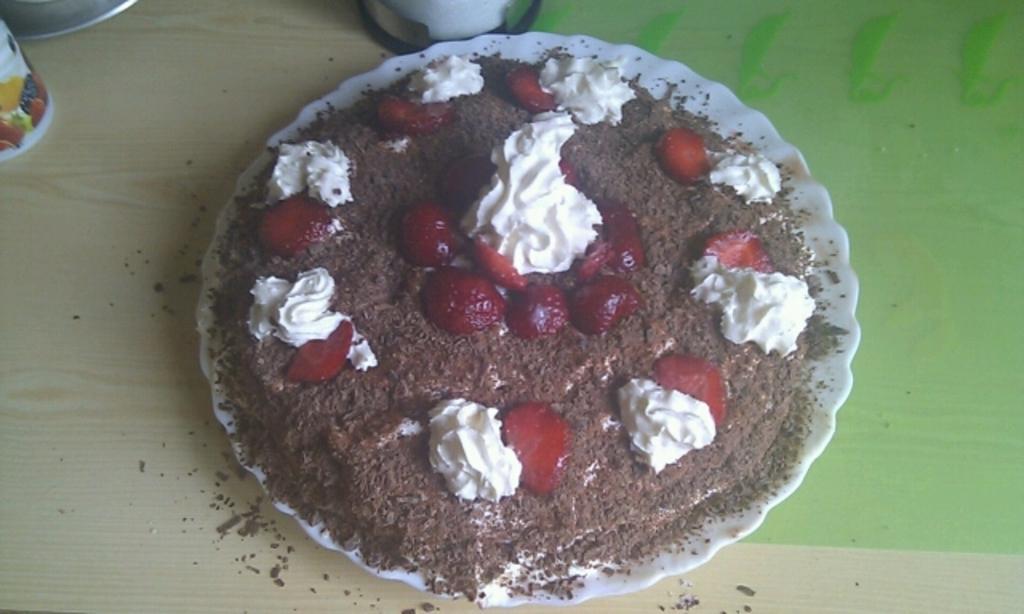Can you describe this image briefly? Here there is a cake with strawberries on it in a plate on a platform and we can also some other items on the platform. 